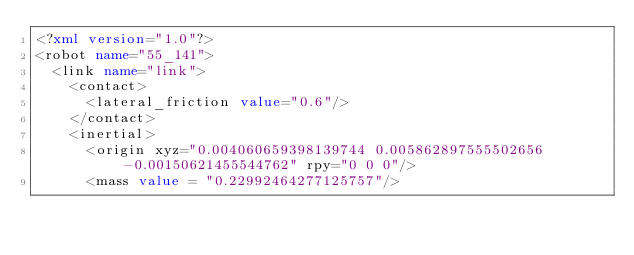<code> <loc_0><loc_0><loc_500><loc_500><_XML_><?xml version="1.0"?>
<robot name="55_141">
  <link name="link">
    <contact>
      <lateral_friction value="0.6"/>
    </contact>
    <inertial>
      <origin xyz="0.004060659398139744 0.005862897555502656 -0.00150621455544762" rpy="0 0 0"/>
      <mass value = "0.22992464277125757"/></code> 